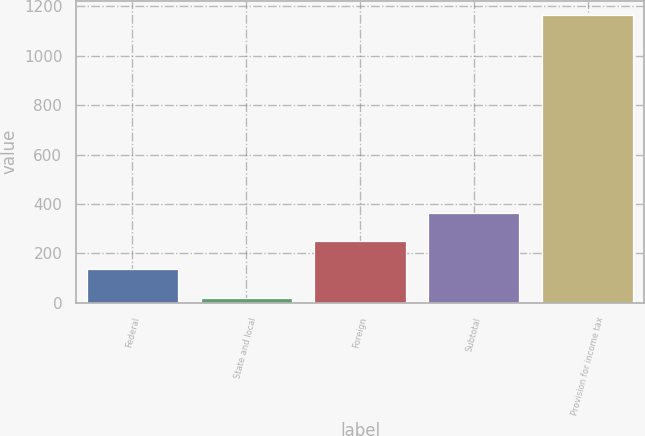Convert chart. <chart><loc_0><loc_0><loc_500><loc_500><bar_chart><fcel>Federal<fcel>State and local<fcel>Foreign<fcel>Subtotal<fcel>Provision for income tax<nl><fcel>135.4<fcel>21<fcel>249.8<fcel>364.2<fcel>1165<nl></chart> 